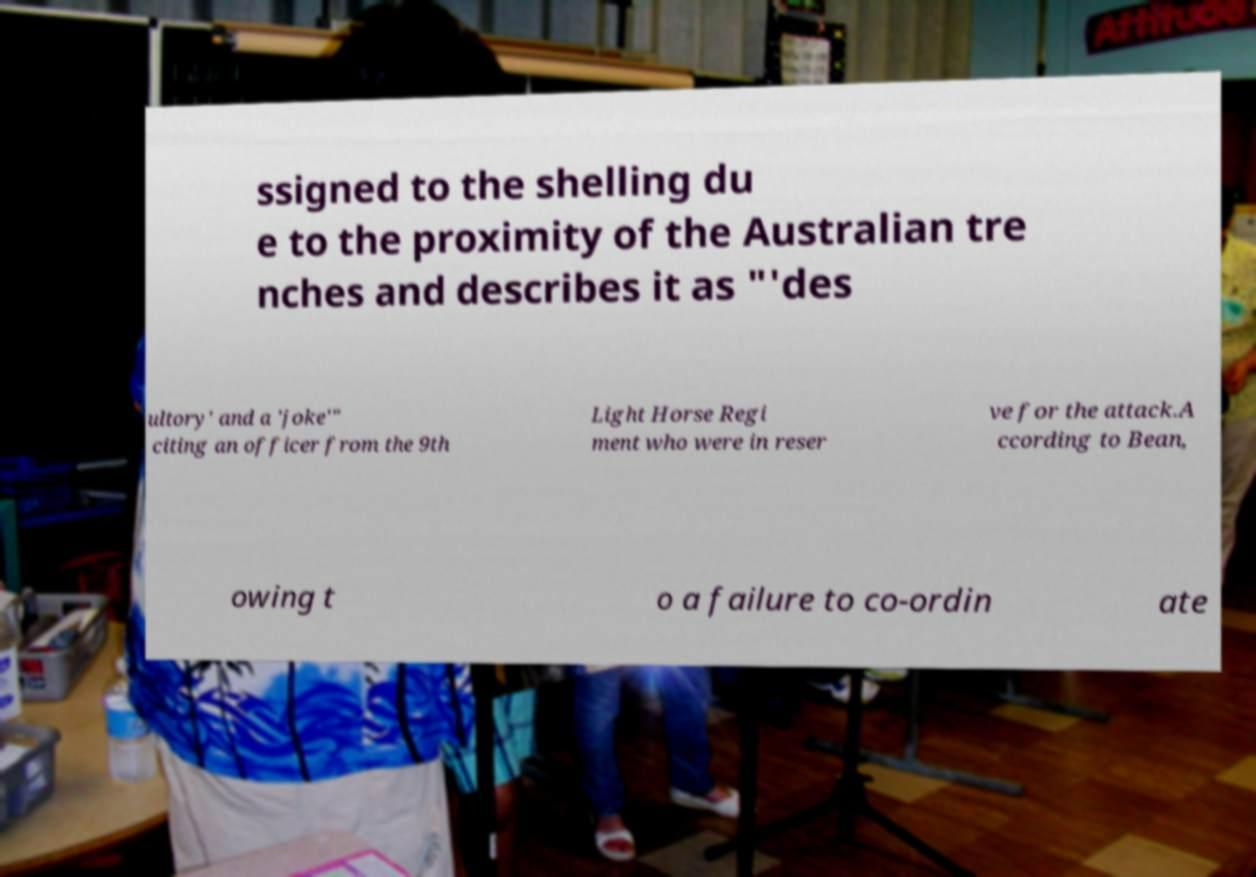Can you accurately transcribe the text from the provided image for me? ssigned to the shelling du e to the proximity of the Australian tre nches and describes it as "'des ultory' and a 'joke'" citing an officer from the 9th Light Horse Regi ment who were in reser ve for the attack.A ccording to Bean, owing t o a failure to co-ordin ate 